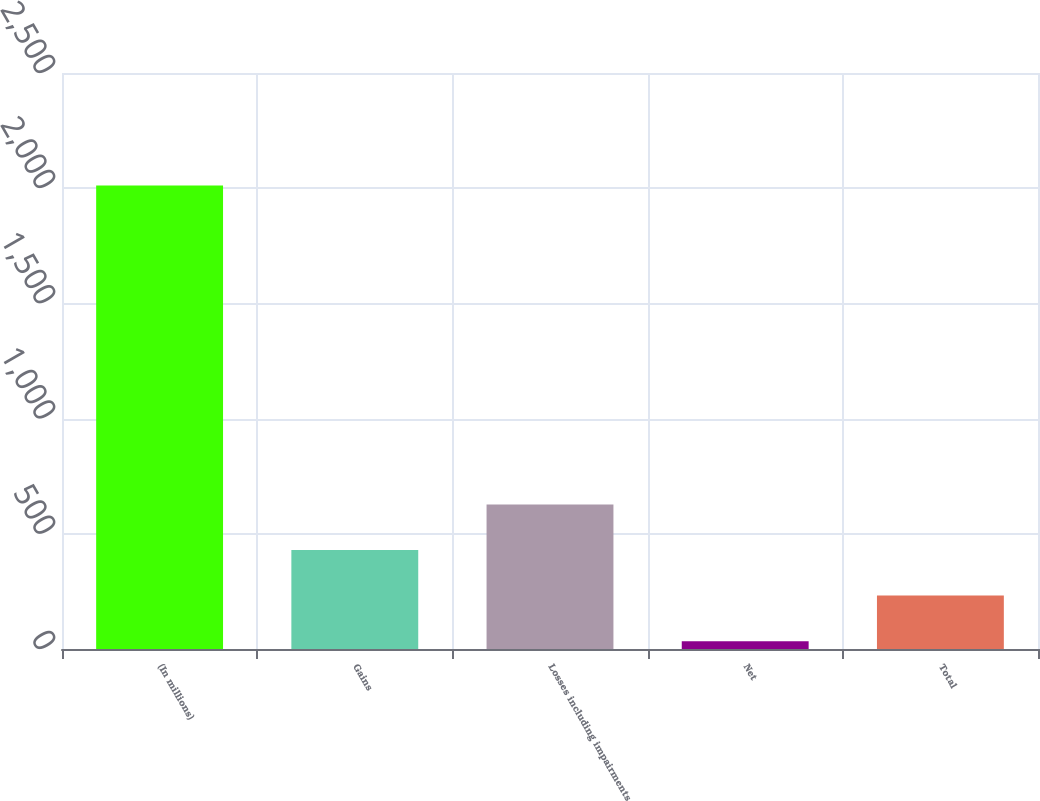<chart> <loc_0><loc_0><loc_500><loc_500><bar_chart><fcel>(In millions)<fcel>Gains<fcel>Losses including impairments<fcel>Net<fcel>Total<nl><fcel>2012<fcel>429.6<fcel>627.4<fcel>34<fcel>231.8<nl></chart> 